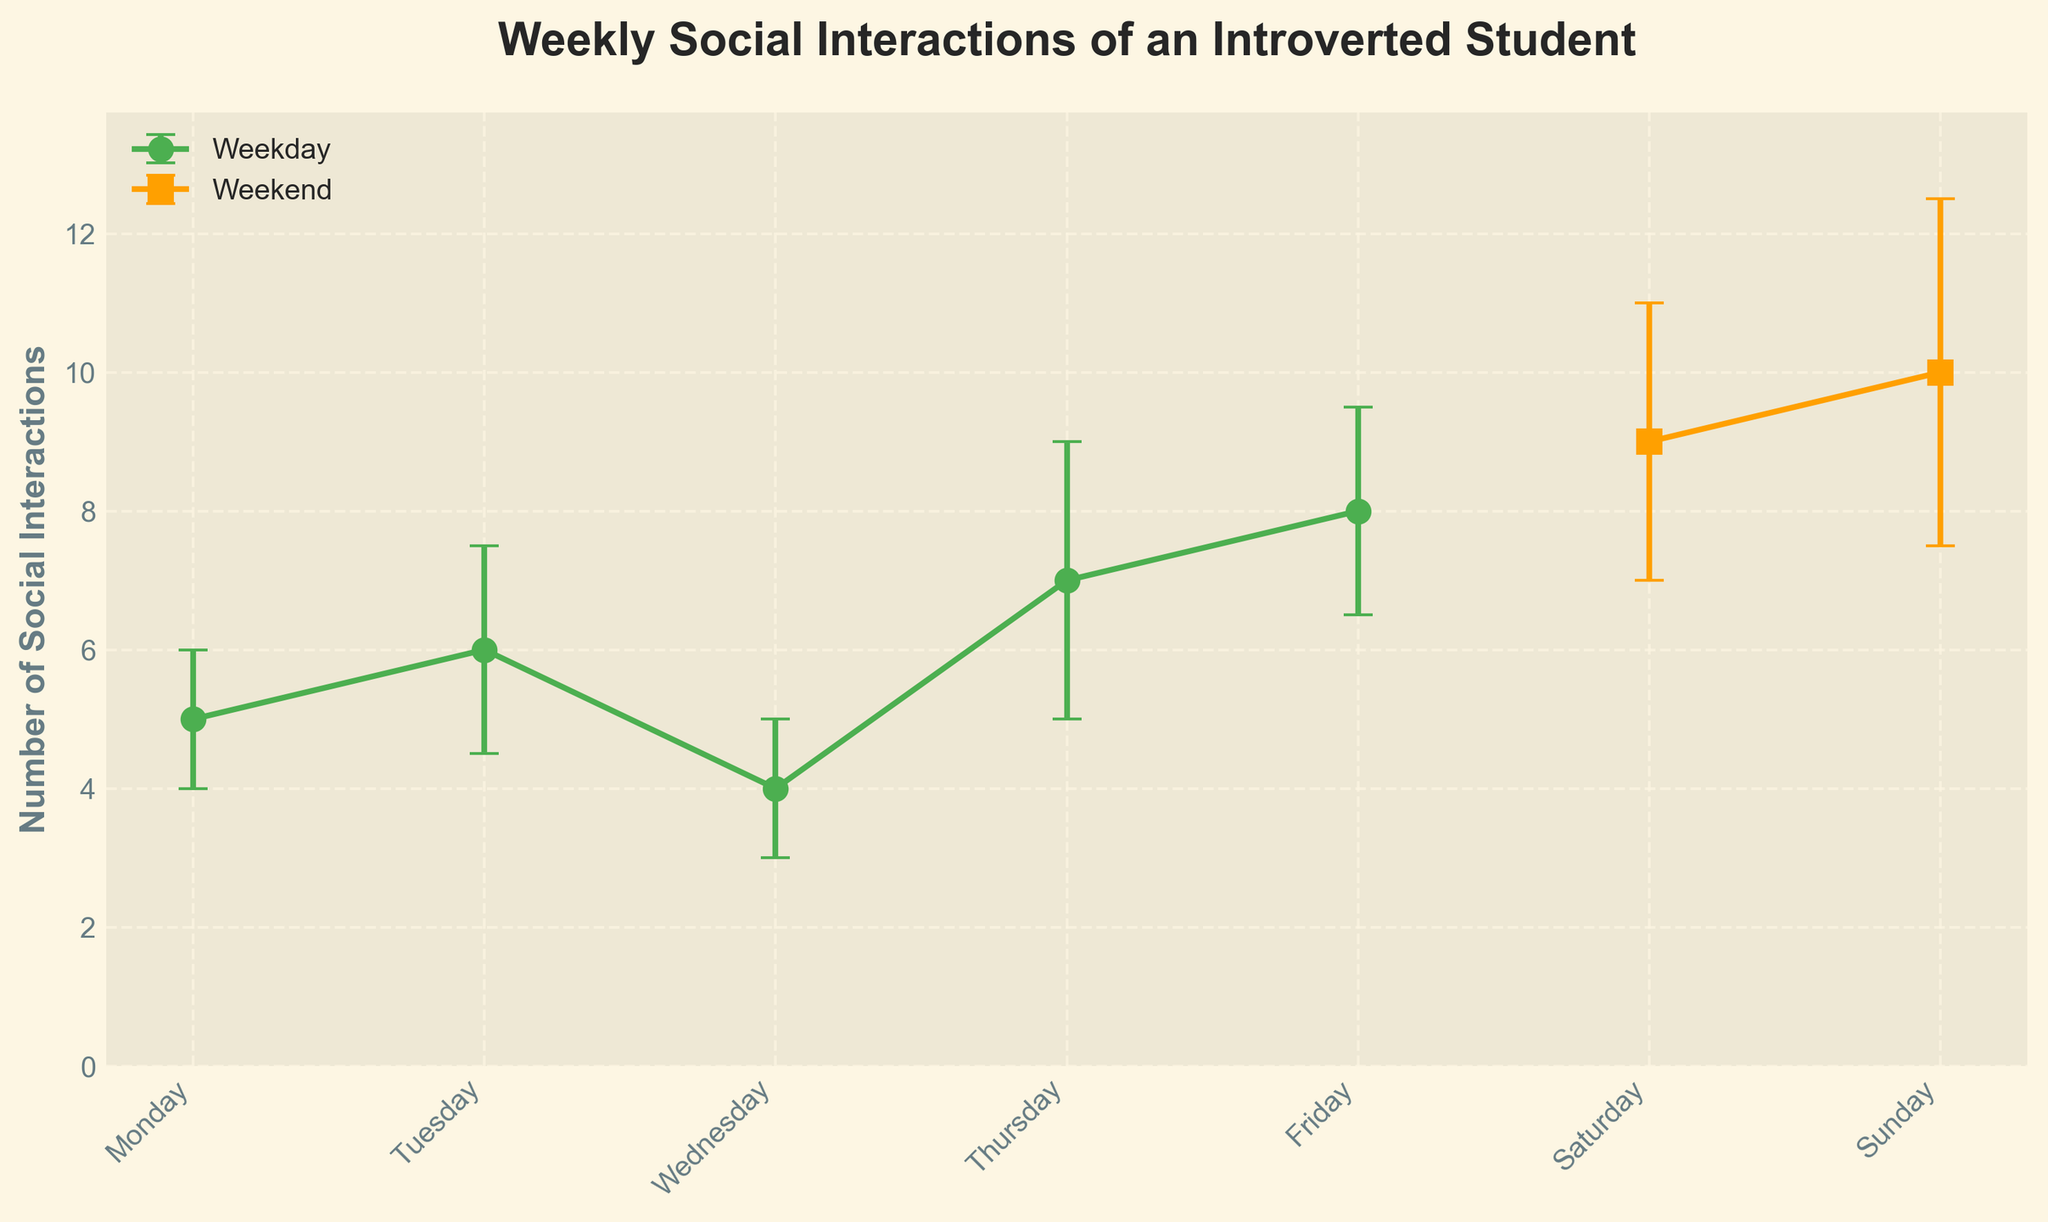What's the title of the plot? The title of the plot is typically positioned towards the top center of the figure, and it’s in bold to make it stand out. The titled used in this plot is "Weekly Social Interactions of an Introverted Student".
Answer: Weekly Social Interactions of an Introverted Student What is the y-axis label in the figure? The y-axis label, which describes what is being measured and plotted along the vertical axis, is seen clearly on the left side. Here, it reads "Number of Social Interactions".
Answer: Number of Social Interactions Which day has the highest number of social interactions? By inspecting the plotted points and error bars, the day with the highest number of social interactions can be identified. Sunday has the plotted point at 10, higher than any other day.
Answer: Sunday Which category seems to have more social interactions on average, weekdays or weekends? To decide which category has more social interactions on average, one must compare the average of the plotted values for each category. Weekday values (5, 6, 4, 7, 8) and weekend values (9 and 10) are considered. Average weekday value: (5+6+4+7+8)/5 = 6, weekend: (9+10)/2 = 9.5.
Answer: Weekends How do Tuesday's social interactions compare to Wednesday's? To compare Tuesday and Wednesday, examine their plotted values directly. Tuesday stands at 6 with an error of 1.5, and Wednesday shows 4 with an error of 1. Therefore, Tuesday has more social interactions.
Answer: Tuesday has more Which day has the smallest error bar? The error bars signify the amount of uncertainty associated with each measurement. By visually inspecting, it is evident that Monday and Wednesday, each with an error of 1, have the smallest error bars.
Answer: Monday and Wednesday Are the error bars generally larger on weekends or weekdays? By observing the size of the error bars, which showcase uncertainty, one can see that weekend days (2 for Saturday, 2.5 for Sunday) have larger error bars compared to weekdays.
Answer: Weekends What is the difference in the number of interactions between Friday and Saturday? To find the difference, subtract the social interactions on Friday from those on Saturday. Saturday has 9 interactions, and Friday has 8. Hence, the difference is 9 - 8.
Answer: 1 What's the average number of social interactions over the entire week? Calculate the sum of all interactions for each day and divide by the number of days. (5 + 6 + 4 + 7 + 8 + 9 + 10) / 7 = 49 / 7. The average is thus 7.
Answer: 7 Which day shows the highest uncertainty in the number of social interactions based on the error bars? To determine the highest uncertainty, look for the day with the largest error bar. Sunday has an error bar of 2.5, which is the largest among all days.
Answer: Sunday 